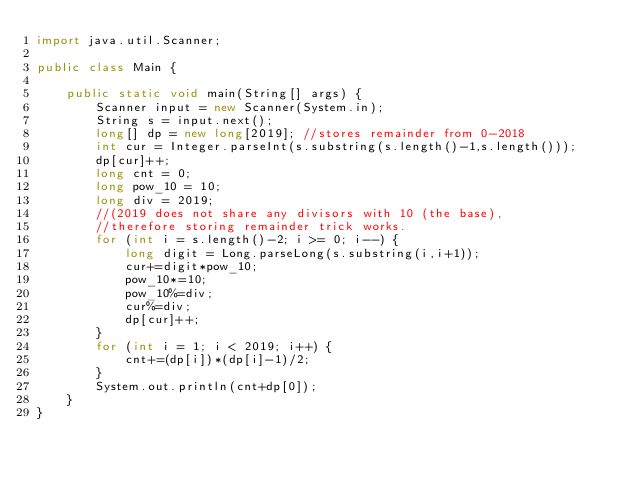Convert code to text. <code><loc_0><loc_0><loc_500><loc_500><_Java_>import java.util.Scanner;

public class Main {

	public static void main(String[] args) {
		Scanner input = new Scanner(System.in);
		String s = input.next();
		long[] dp = new long[2019]; //stores remainder from 0-2018
		int cur = Integer.parseInt(s.substring(s.length()-1,s.length()));
		dp[cur]++;
		long cnt = 0;
		long pow_10 = 10;
		long div = 2019;
		//(2019 does not share any divisors with 10 (the base), 
		//therefore storing remainder trick works.
		for (int i = s.length()-2; i >= 0; i--) {
			long digit = Long.parseLong(s.substring(i,i+1));
			cur+=digit*pow_10;
			pow_10*=10;
			pow_10%=div;
			cur%=div;
			dp[cur]++;
		}
		for (int i = 1; i < 2019; i++) {
			cnt+=(dp[i])*(dp[i]-1)/2;
		}
		System.out.println(cnt+dp[0]);
	}
}</code> 